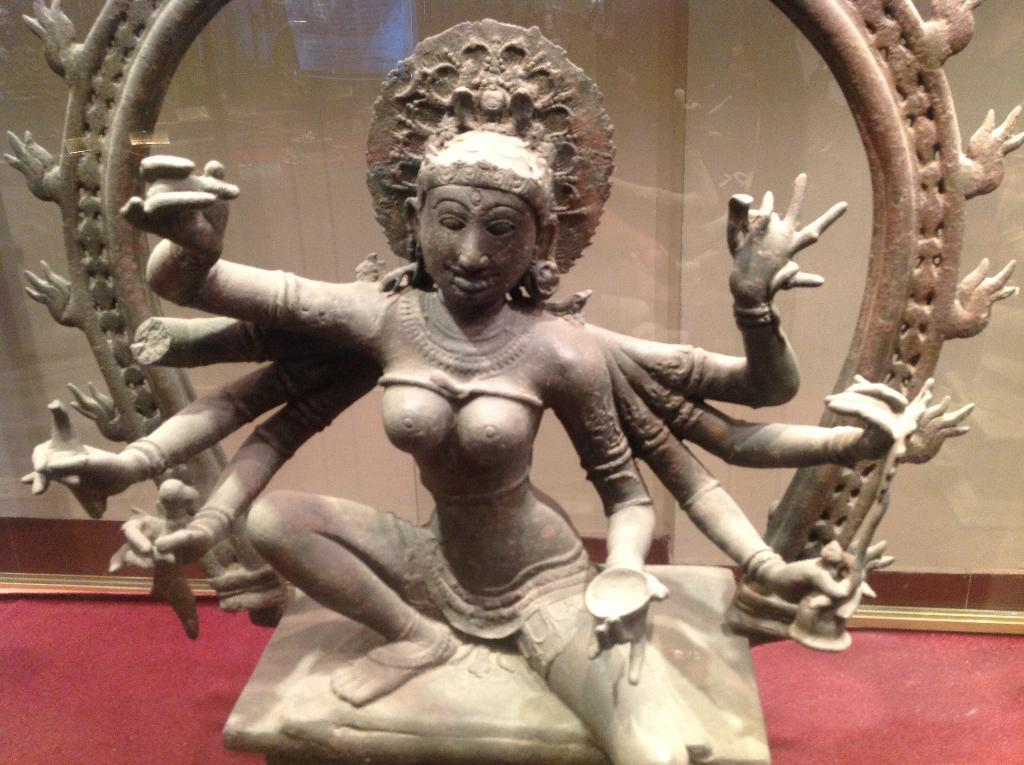What is the main subject of the subject of the image? The main subject of the image is a statue with many hands. What is on top of the statue's head? The statue has a crown. What color is the surface on which the statue is placed? The statue is placed on a red color surface. What can be seen in the background of the image? There is a wall in the background of the image. How many times does the statue sneeze in the image? There is no indication in the image that the statue is sneezing, and therefore no such activity can be observed. 